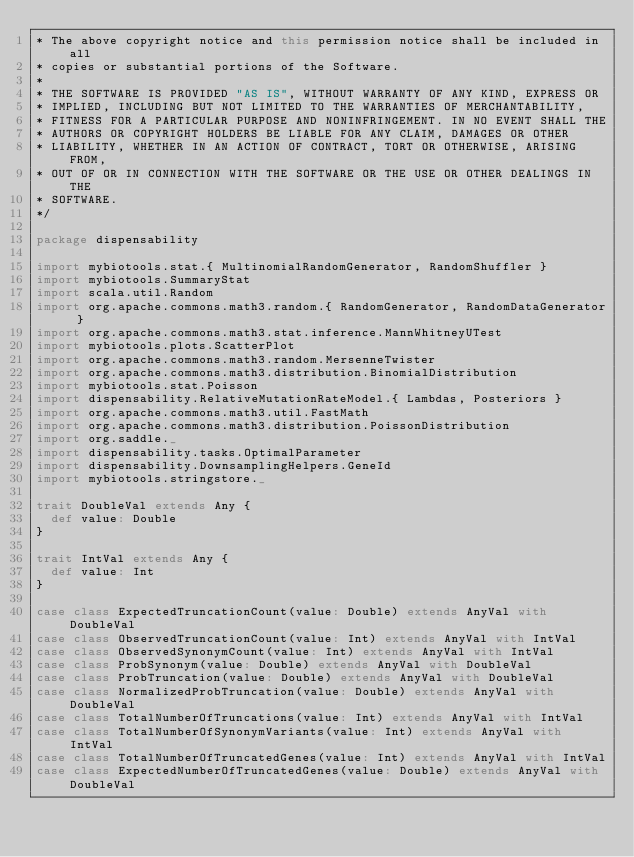<code> <loc_0><loc_0><loc_500><loc_500><_Scala_>* The above copyright notice and this permission notice shall be included in all
* copies or substantial portions of the Software.
*
* THE SOFTWARE IS PROVIDED "AS IS", WITHOUT WARRANTY OF ANY KIND, EXPRESS OR 
* IMPLIED, INCLUDING BUT NOT LIMITED TO THE WARRANTIES OF MERCHANTABILITY, 
* FITNESS FOR A PARTICULAR PURPOSE AND NONINFRINGEMENT. IN NO EVENT SHALL THE 
* AUTHORS OR COPYRIGHT HOLDERS BE LIABLE FOR ANY CLAIM, DAMAGES OR OTHER 
* LIABILITY, WHETHER IN AN ACTION OF CONTRACT, TORT OR OTHERWISE, ARISING FROM, 
* OUT OF OR IN CONNECTION WITH THE SOFTWARE OR THE USE OR OTHER DEALINGS IN THE 
* SOFTWARE.
*/

package dispensability

import mybiotools.stat.{ MultinomialRandomGenerator, RandomShuffler }
import mybiotools.SummaryStat
import scala.util.Random
import org.apache.commons.math3.random.{ RandomGenerator, RandomDataGenerator }
import org.apache.commons.math3.stat.inference.MannWhitneyUTest
import mybiotools.plots.ScatterPlot
import org.apache.commons.math3.random.MersenneTwister
import org.apache.commons.math3.distribution.BinomialDistribution
import mybiotools.stat.Poisson
import dispensability.RelativeMutationRateModel.{ Lambdas, Posteriors }
import org.apache.commons.math3.util.FastMath
import org.apache.commons.math3.distribution.PoissonDistribution
import org.saddle._
import dispensability.tasks.OptimalParameter
import dispensability.DownsamplingHelpers.GeneId
import mybiotools.stringstore._

trait DoubleVal extends Any {
  def value: Double
}

trait IntVal extends Any {
  def value: Int
}

case class ExpectedTruncationCount(value: Double) extends AnyVal with DoubleVal
case class ObservedTruncationCount(value: Int) extends AnyVal with IntVal
case class ObservedSynonymCount(value: Int) extends AnyVal with IntVal
case class ProbSynonym(value: Double) extends AnyVal with DoubleVal
case class ProbTruncation(value: Double) extends AnyVal with DoubleVal
case class NormalizedProbTruncation(value: Double) extends AnyVal with DoubleVal
case class TotalNumberOfTruncations(value: Int) extends AnyVal with IntVal
case class TotalNumberOfSynonymVariants(value: Int) extends AnyVal with IntVal
case class TotalNumberOfTruncatedGenes(value: Int) extends AnyVal with IntVal
case class ExpectedNumberOfTruncatedGenes(value: Double) extends AnyVal with DoubleVal
</code> 